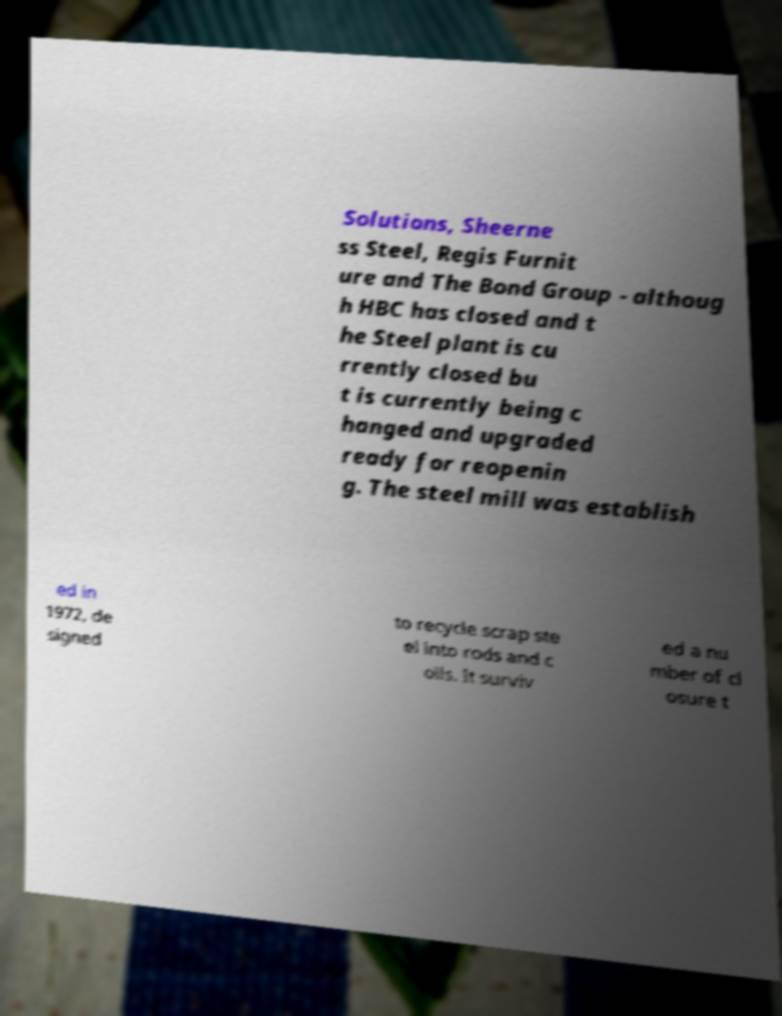Please read and relay the text visible in this image. What does it say? Solutions, Sheerne ss Steel, Regis Furnit ure and The Bond Group - althoug h HBC has closed and t he Steel plant is cu rrently closed bu t is currently being c hanged and upgraded ready for reopenin g. The steel mill was establish ed in 1972, de signed to recycle scrap ste el into rods and c oils. It surviv ed a nu mber of cl osure t 